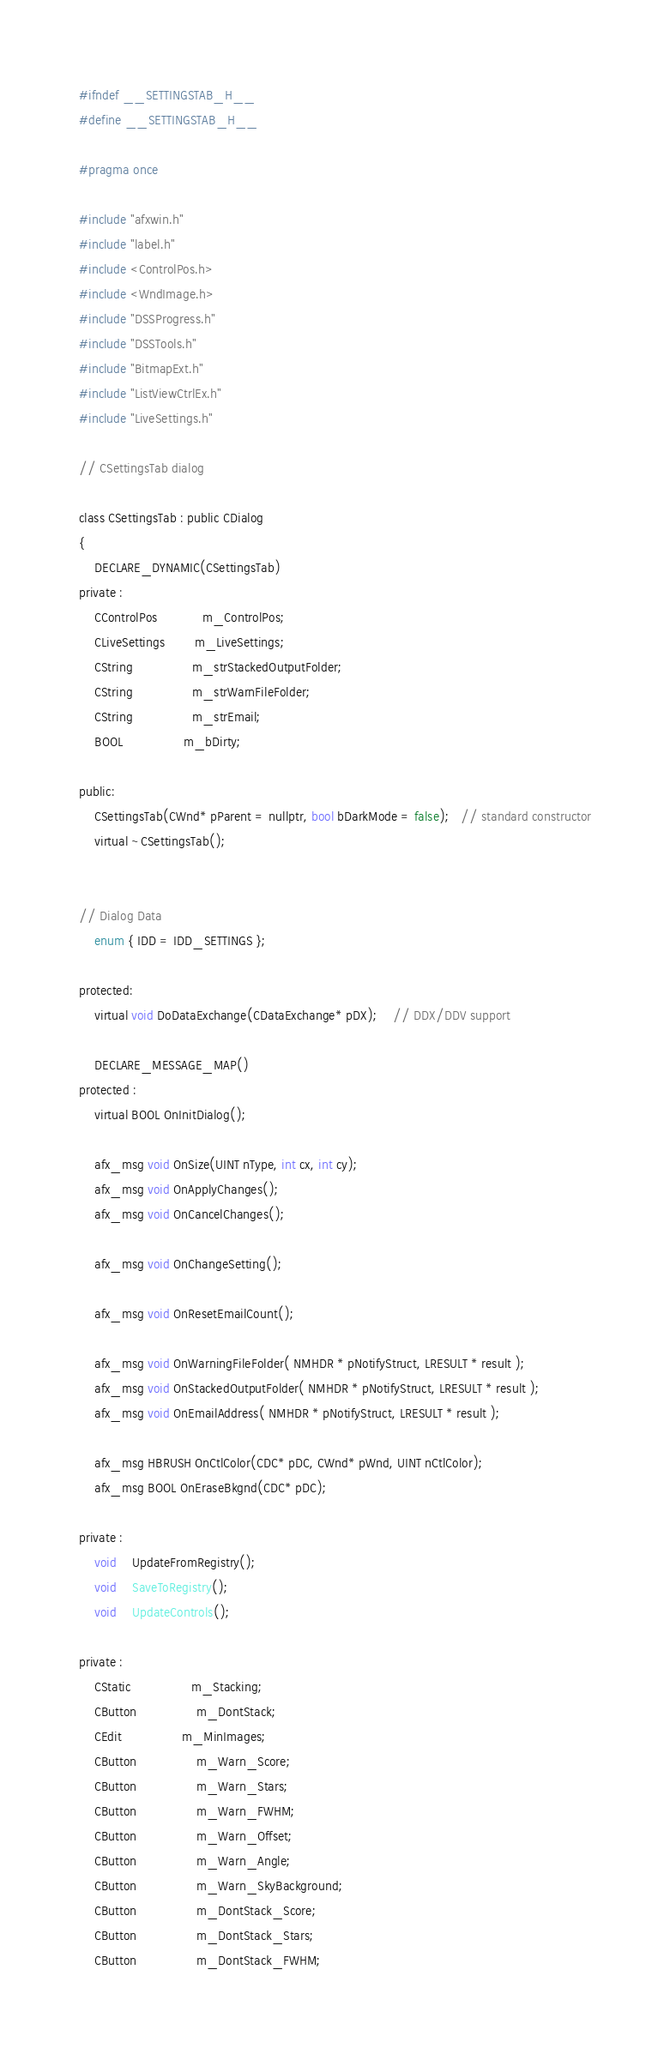Convert code to text. <code><loc_0><loc_0><loc_500><loc_500><_C_>#ifndef __SETTINGSTAB_H__
#define __SETTINGSTAB_H__

#pragma once

#include "afxwin.h"
#include "label.h"
#include <ControlPos.h>
#include <WndImage.h>
#include "DSSProgress.h"
#include "DSSTools.h"
#include "BitmapExt.h"
#include "ListViewCtrlEx.h"
#include "LiveSettings.h"

// CSettingsTab dialog

class CSettingsTab : public CDialog
{
	DECLARE_DYNAMIC(CSettingsTab)
private :
	CControlPos			m_ControlPos;
	CLiveSettings		m_LiveSettings;
	CString				m_strStackedOutputFolder;
	CString				m_strWarnFileFolder;
	CString				m_strEmail;
	BOOL				m_bDirty;

public:
	CSettingsTab(CWnd* pParent = nullptr, bool bDarkMode = false);   // standard constructor
	virtual ~CSettingsTab();


// Dialog Data
	enum { IDD = IDD_SETTINGS };

protected:
	virtual void DoDataExchange(CDataExchange* pDX);    // DDX/DDV support

	DECLARE_MESSAGE_MAP()
protected :
	virtual BOOL OnInitDialog();

	afx_msg void OnSize(UINT nType, int cx, int cy);
	afx_msg void OnApplyChanges();
	afx_msg void OnCancelChanges();

	afx_msg void OnChangeSetting();

	afx_msg void OnResetEmailCount();

	afx_msg void OnWarningFileFolder( NMHDR * pNotifyStruct, LRESULT * result );
	afx_msg void OnStackedOutputFolder( NMHDR * pNotifyStruct, LRESULT * result );
	afx_msg void OnEmailAddress( NMHDR * pNotifyStruct, LRESULT * result );

	afx_msg HBRUSH OnCtlColor(CDC* pDC, CWnd* pWnd, UINT nCtlColor);
	afx_msg BOOL OnEraseBkgnd(CDC* pDC);

private :
	void	UpdateFromRegistry();
	void	SaveToRegistry();
	void	UpdateControls();

private :
	CStatic				m_Stacking;
	CButton				m_DontStack;
	CEdit				m_MinImages;
	CButton				m_Warn_Score;
	CButton				m_Warn_Stars;
	CButton				m_Warn_FWHM;
	CButton				m_Warn_Offset;
	CButton				m_Warn_Angle;
	CButton				m_Warn_SkyBackground;
	CButton				m_DontStack_Score;
	CButton				m_DontStack_Stars;
	CButton				m_DontStack_FWHM;</code> 